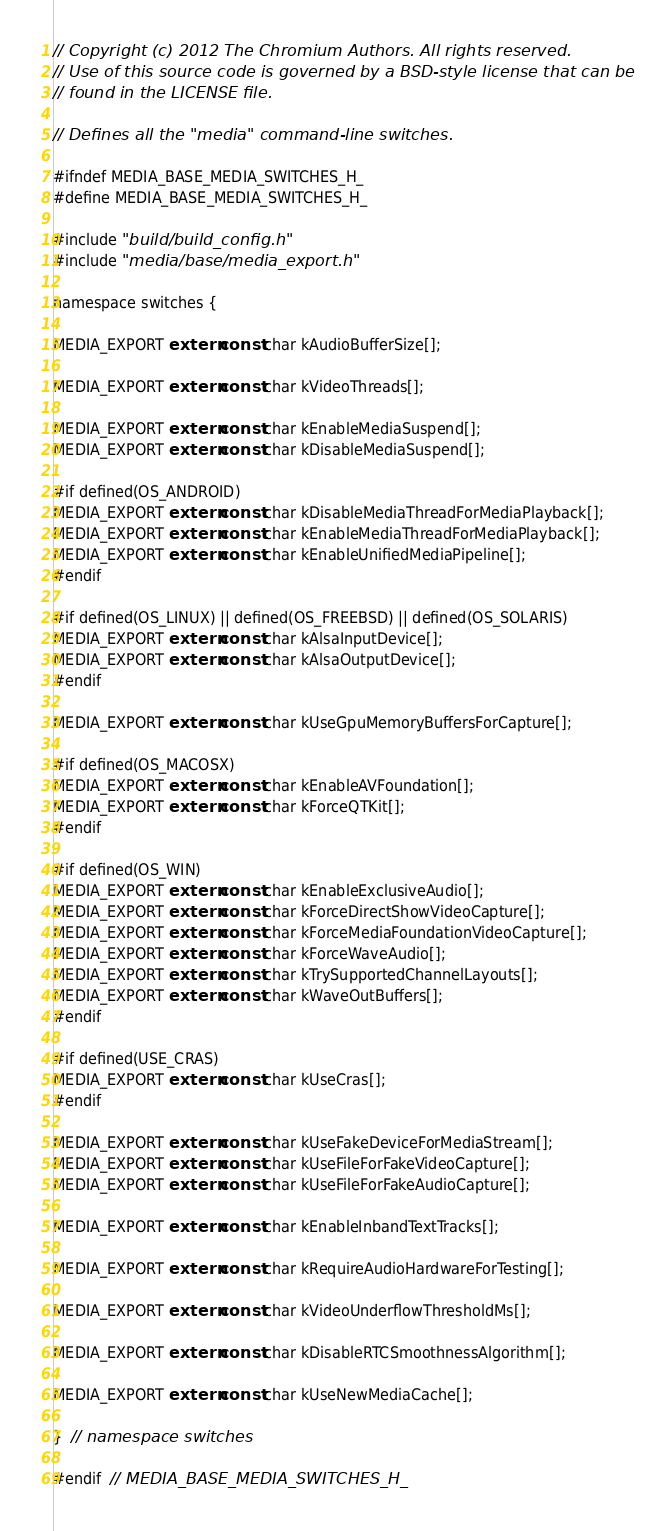Convert code to text. <code><loc_0><loc_0><loc_500><loc_500><_C_>// Copyright (c) 2012 The Chromium Authors. All rights reserved.
// Use of this source code is governed by a BSD-style license that can be
// found in the LICENSE file.

// Defines all the "media" command-line switches.

#ifndef MEDIA_BASE_MEDIA_SWITCHES_H_
#define MEDIA_BASE_MEDIA_SWITCHES_H_

#include "build/build_config.h"
#include "media/base/media_export.h"

namespace switches {

MEDIA_EXPORT extern const char kAudioBufferSize[];

MEDIA_EXPORT extern const char kVideoThreads[];

MEDIA_EXPORT extern const char kEnableMediaSuspend[];
MEDIA_EXPORT extern const char kDisableMediaSuspend[];

#if defined(OS_ANDROID)
MEDIA_EXPORT extern const char kDisableMediaThreadForMediaPlayback[];
MEDIA_EXPORT extern const char kEnableMediaThreadForMediaPlayback[];
MEDIA_EXPORT extern const char kEnableUnifiedMediaPipeline[];
#endif

#if defined(OS_LINUX) || defined(OS_FREEBSD) || defined(OS_SOLARIS)
MEDIA_EXPORT extern const char kAlsaInputDevice[];
MEDIA_EXPORT extern const char kAlsaOutputDevice[];
#endif

MEDIA_EXPORT extern const char kUseGpuMemoryBuffersForCapture[];

#if defined(OS_MACOSX)
MEDIA_EXPORT extern const char kEnableAVFoundation[];
MEDIA_EXPORT extern const char kForceQTKit[];
#endif

#if defined(OS_WIN)
MEDIA_EXPORT extern const char kEnableExclusiveAudio[];
MEDIA_EXPORT extern const char kForceDirectShowVideoCapture[];
MEDIA_EXPORT extern const char kForceMediaFoundationVideoCapture[];
MEDIA_EXPORT extern const char kForceWaveAudio[];
MEDIA_EXPORT extern const char kTrySupportedChannelLayouts[];
MEDIA_EXPORT extern const char kWaveOutBuffers[];
#endif

#if defined(USE_CRAS)
MEDIA_EXPORT extern const char kUseCras[];
#endif

MEDIA_EXPORT extern const char kUseFakeDeviceForMediaStream[];
MEDIA_EXPORT extern const char kUseFileForFakeVideoCapture[];
MEDIA_EXPORT extern const char kUseFileForFakeAudioCapture[];

MEDIA_EXPORT extern const char kEnableInbandTextTracks[];

MEDIA_EXPORT extern const char kRequireAudioHardwareForTesting[];

MEDIA_EXPORT extern const char kVideoUnderflowThresholdMs[];

MEDIA_EXPORT extern const char kDisableRTCSmoothnessAlgorithm[];

MEDIA_EXPORT extern const char kUseNewMediaCache[];

}  // namespace switches

#endif  // MEDIA_BASE_MEDIA_SWITCHES_H_
</code> 